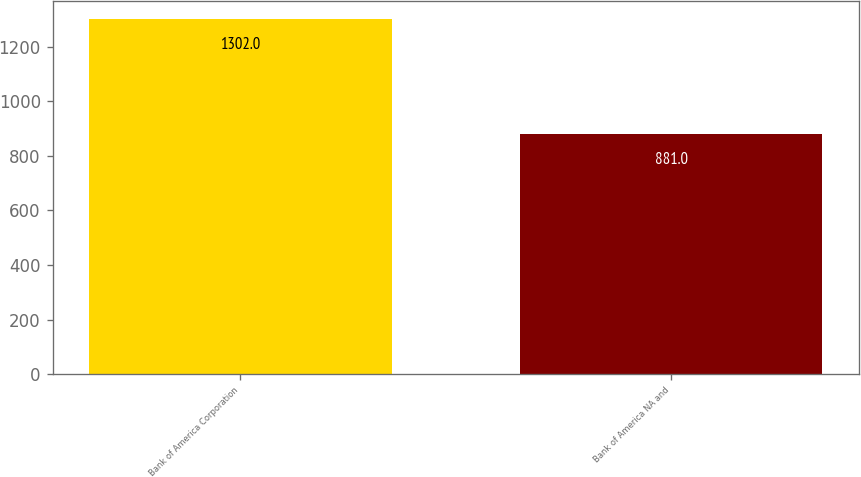Convert chart. <chart><loc_0><loc_0><loc_500><loc_500><bar_chart><fcel>Bank of America Corporation<fcel>Bank of America NA and<nl><fcel>1302<fcel>881<nl></chart> 